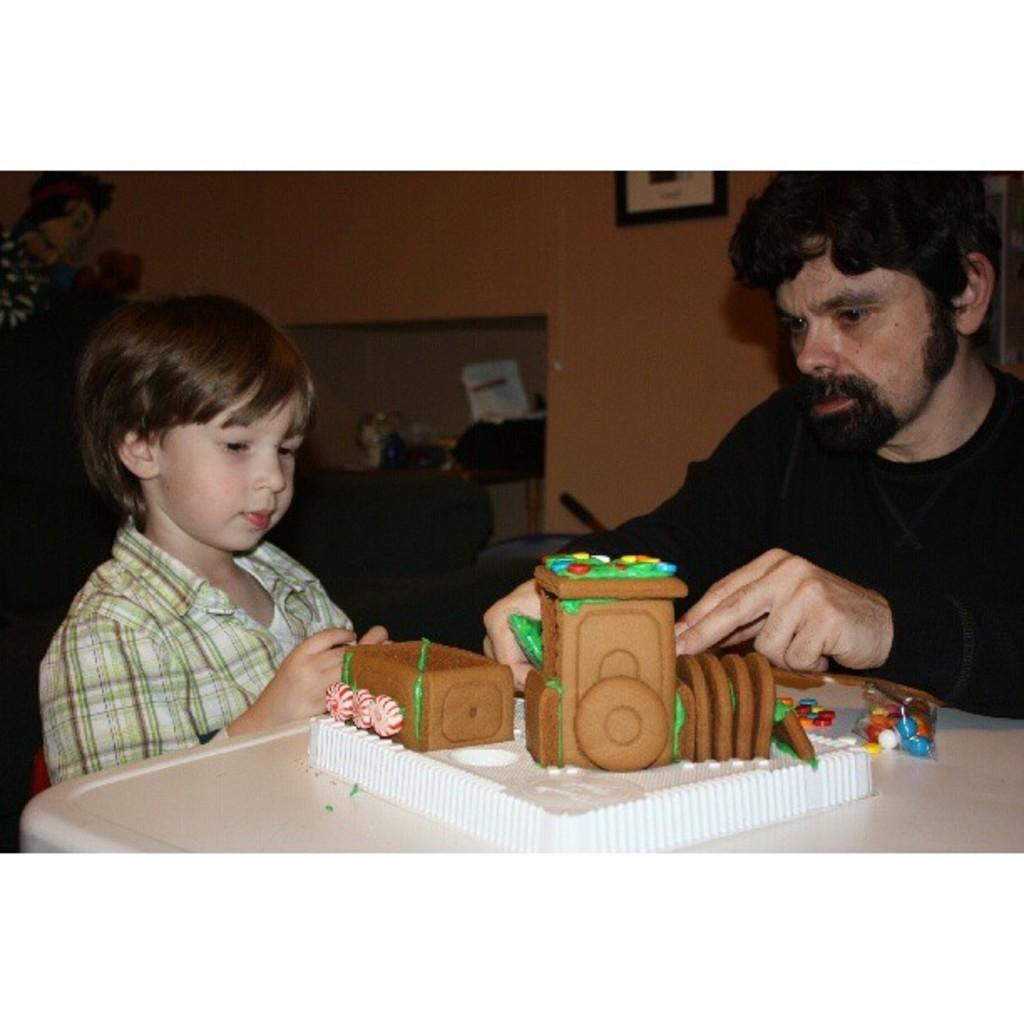Who can be seen in the foreground of the image? There is a man and a boy in the foreground of the image. What are the man and boy doing in the image? The man and boy are sitting in front of a table. What is on the table in the image? There is a cake and gems on the table. What can be seen in the background of the image? There is a frame and a wall in the background of the image, along with other objects. What type of feast is being prepared in the image? There is no indication of a feast being prepared in the image; it simply shows a man and a boy sitting at a table with a cake and gems. What type of plough is visible in the image? There is no plough present in the image. 